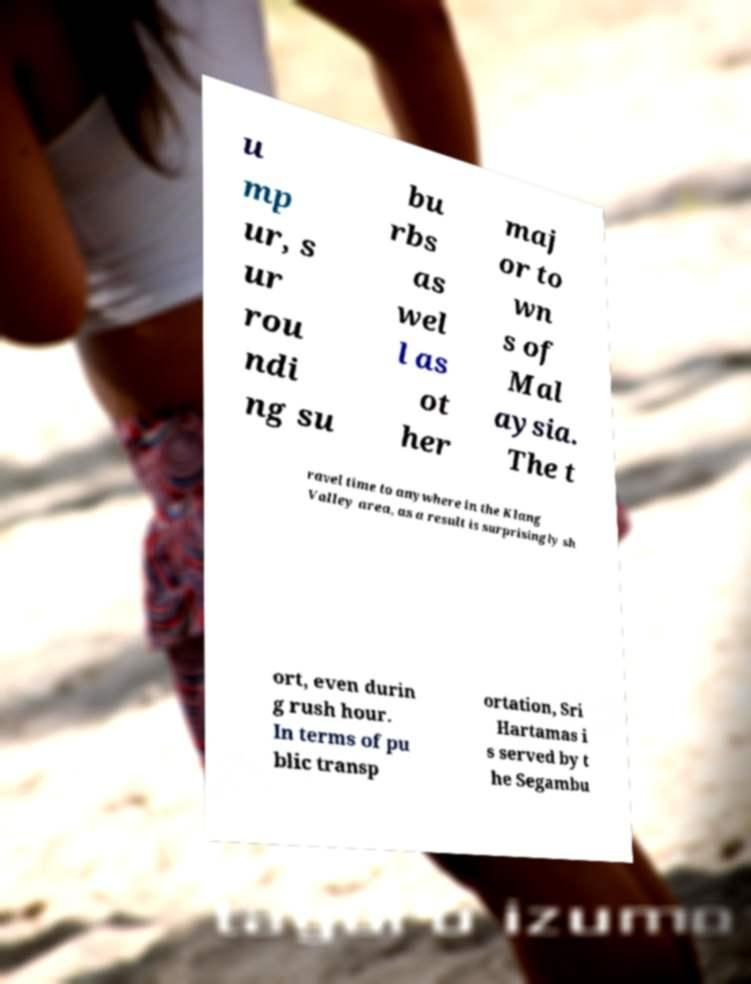I need the written content from this picture converted into text. Can you do that? u mp ur, s ur rou ndi ng su bu rbs as wel l as ot her maj or to wn s of Mal aysia. The t ravel time to anywhere in the Klang Valley area, as a result is surprisingly sh ort, even durin g rush hour. In terms of pu blic transp ortation, Sri Hartamas i s served by t he Segambu 